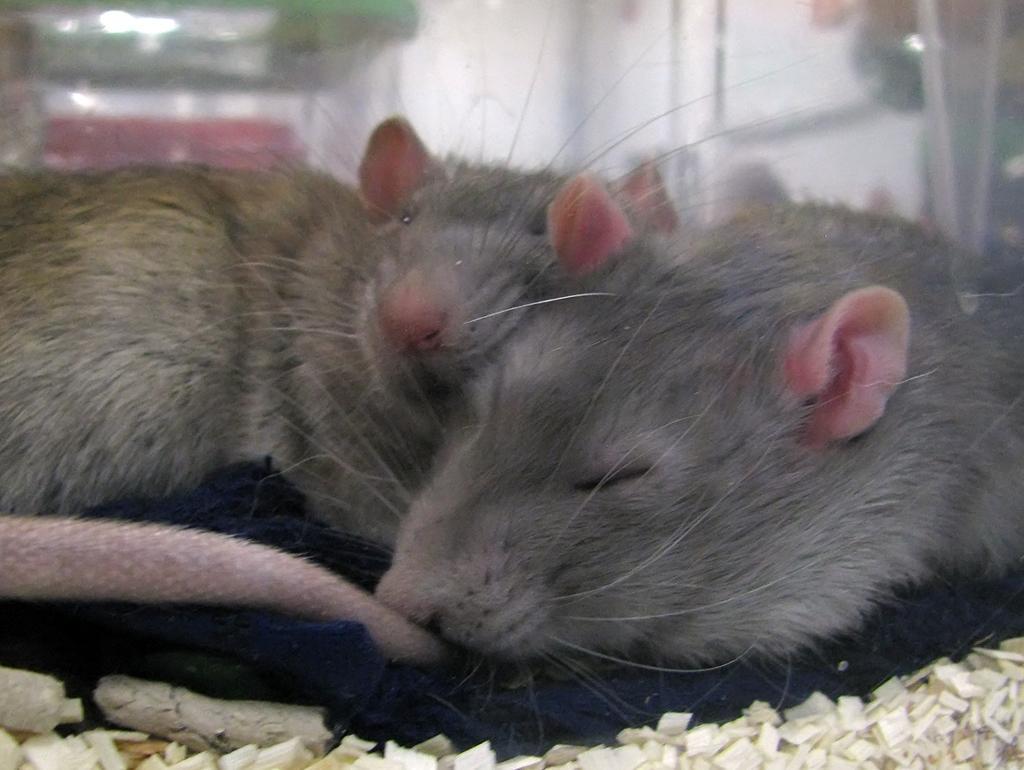Please provide a concise description of this image. In this picture I see 2 rats in front and I see few white color things and I see that it is blurred in the background. 